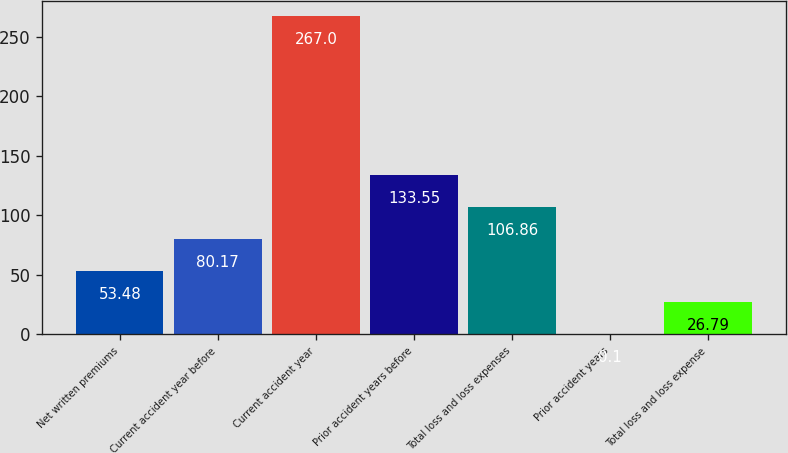<chart> <loc_0><loc_0><loc_500><loc_500><bar_chart><fcel>Net written premiums<fcel>Current accident year before<fcel>Current accident year<fcel>Prior accident years before<fcel>Total loss and loss expenses<fcel>Prior accident years<fcel>Total loss and loss expense<nl><fcel>53.48<fcel>80.17<fcel>267<fcel>133.55<fcel>106.86<fcel>0.1<fcel>26.79<nl></chart> 